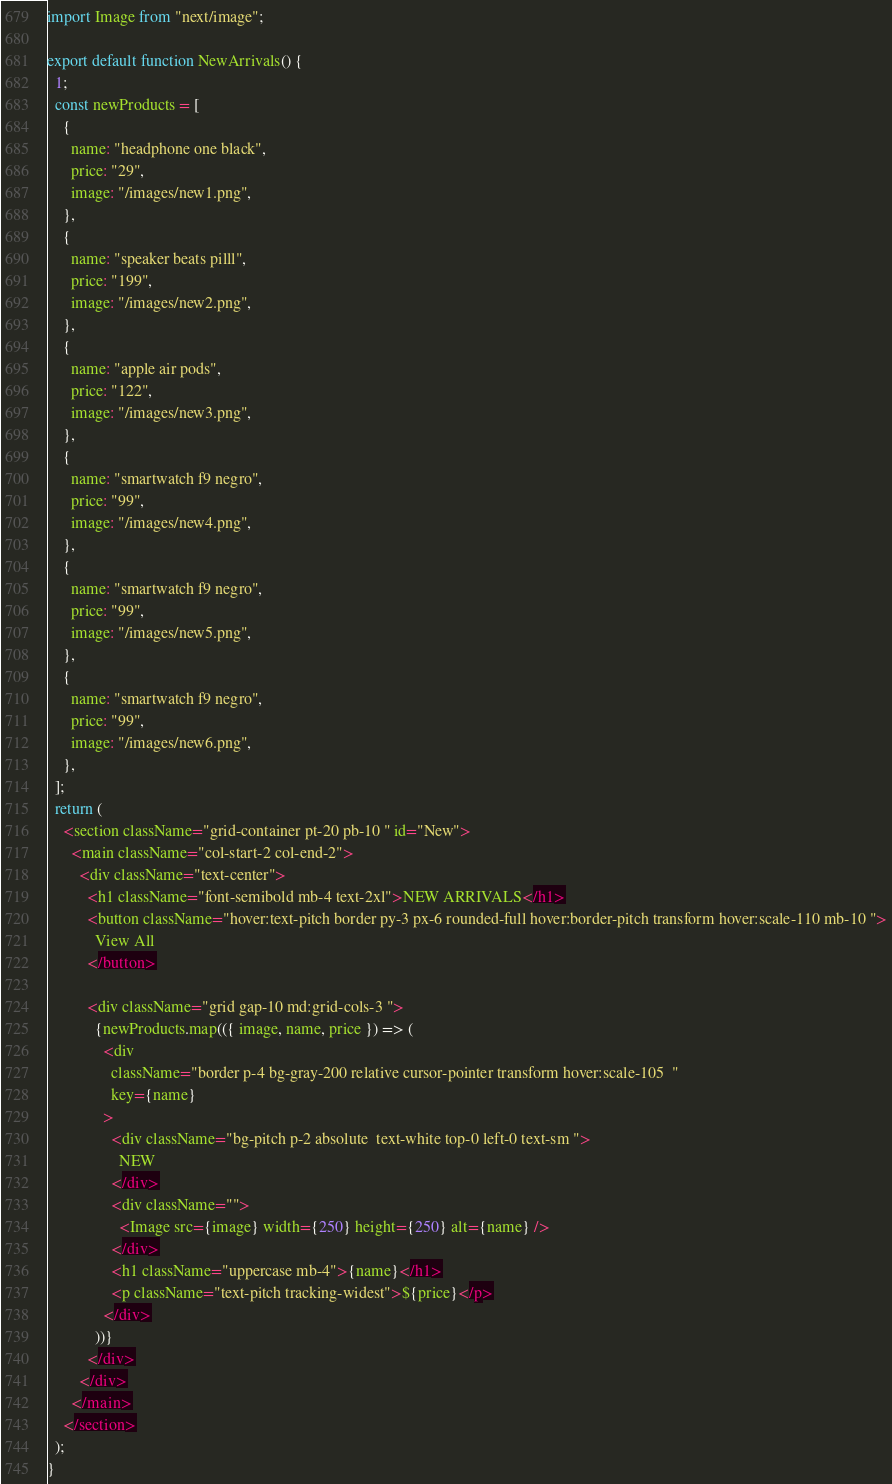<code> <loc_0><loc_0><loc_500><loc_500><_TypeScript_>import Image from "next/image";

export default function NewArrivals() {
  1;
  const newProducts = [
    {
      name: "headphone one black",
      price: "29",
      image: "/images/new1.png",
    },
    {
      name: "speaker beats pilll",
      price: "199",
      image: "/images/new2.png",
    },
    {
      name: "apple air pods",
      price: "122",
      image: "/images/new3.png",
    },
    {
      name: "smartwatch f9 negro",
      price: "99",
      image: "/images/new4.png",
    },
    {
      name: "smartwatch f9 negro",
      price: "99",
      image: "/images/new5.png",
    },
    {
      name: "smartwatch f9 negro",
      price: "99",
      image: "/images/new6.png",
    },
  ];
  return (
    <section className="grid-container pt-20 pb-10 " id="New">
      <main className="col-start-2 col-end-2">
        <div className="text-center">
          <h1 className="font-semibold mb-4 text-2xl">NEW ARRIVALS</h1>
          <button className="hover:text-pitch border py-3 px-6 rounded-full hover:border-pitch transform hover:scale-110 mb-10 ">
            View All
          </button>

          <div className="grid gap-10 md:grid-cols-3 ">
            {newProducts.map(({ image, name, price }) => (
              <div
                className="border p-4 bg-gray-200 relative cursor-pointer transform hover:scale-105  "
                key={name}
              >
                <div className="bg-pitch p-2 absolute  text-white top-0 left-0 text-sm ">
                  NEW
                </div>
                <div className="">
                  <Image src={image} width={250} height={250} alt={name} />
                </div>
                <h1 className="uppercase mb-4">{name}</h1>
                <p className="text-pitch tracking-widest">${price}</p>
              </div>
            ))}
          </div>
        </div>
      </main>
    </section>
  );
}
</code> 